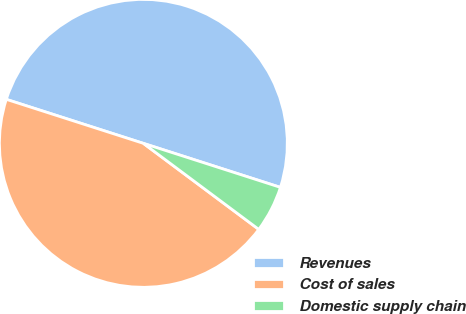Convert chart. <chart><loc_0><loc_0><loc_500><loc_500><pie_chart><fcel>Revenues<fcel>Cost of sales<fcel>Domestic supply chain<nl><fcel>50.0%<fcel>44.75%<fcel>5.25%<nl></chart> 